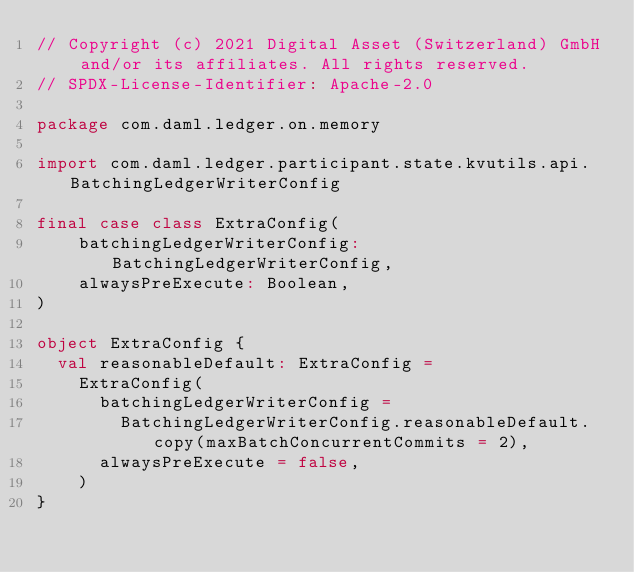Convert code to text. <code><loc_0><loc_0><loc_500><loc_500><_Scala_>// Copyright (c) 2021 Digital Asset (Switzerland) GmbH and/or its affiliates. All rights reserved.
// SPDX-License-Identifier: Apache-2.0

package com.daml.ledger.on.memory

import com.daml.ledger.participant.state.kvutils.api.BatchingLedgerWriterConfig

final case class ExtraConfig(
    batchingLedgerWriterConfig: BatchingLedgerWriterConfig,
    alwaysPreExecute: Boolean,
)

object ExtraConfig {
  val reasonableDefault: ExtraConfig =
    ExtraConfig(
      batchingLedgerWriterConfig =
        BatchingLedgerWriterConfig.reasonableDefault.copy(maxBatchConcurrentCommits = 2),
      alwaysPreExecute = false,
    )
}
</code> 